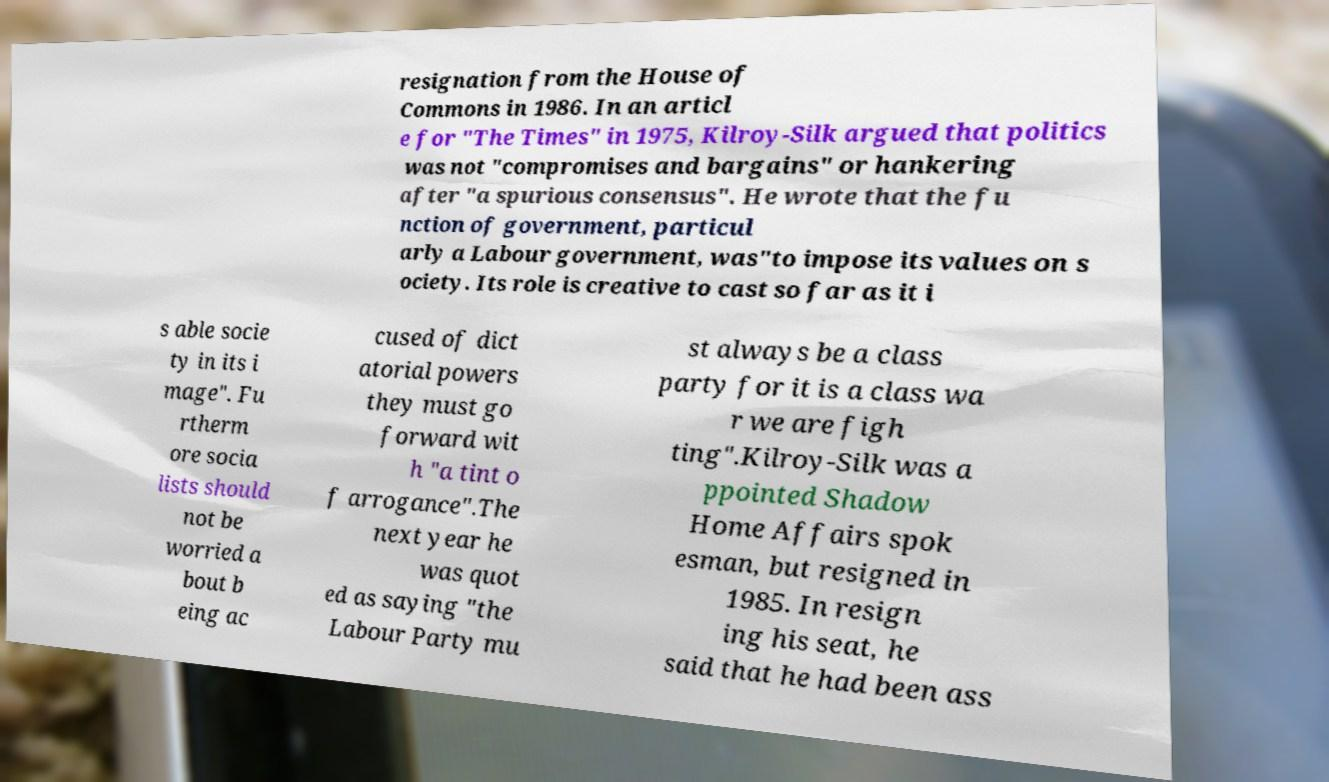Please identify and transcribe the text found in this image. resignation from the House of Commons in 1986. In an articl e for "The Times" in 1975, Kilroy-Silk argued that politics was not "compromises and bargains" or hankering after "a spurious consensus". He wrote that the fu nction of government, particul arly a Labour government, was"to impose its values on s ociety. Its role is creative to cast so far as it i s able socie ty in its i mage". Fu rtherm ore socia lists should not be worried a bout b eing ac cused of dict atorial powers they must go forward wit h "a tint o f arrogance".The next year he was quot ed as saying "the Labour Party mu st always be a class party for it is a class wa r we are figh ting".Kilroy-Silk was a ppointed Shadow Home Affairs spok esman, but resigned in 1985. In resign ing his seat, he said that he had been ass 